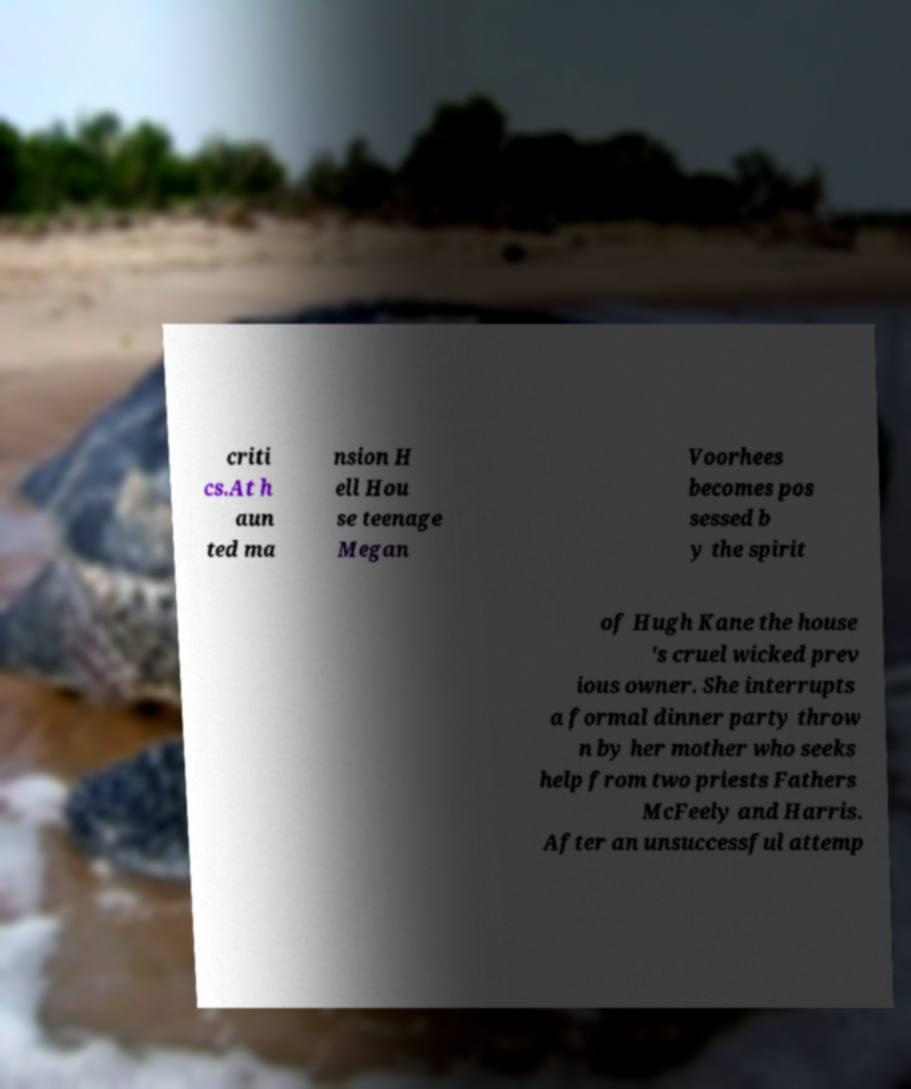Could you extract and type out the text from this image? criti cs.At h aun ted ma nsion H ell Hou se teenage Megan Voorhees becomes pos sessed b y the spirit of Hugh Kane the house 's cruel wicked prev ious owner. She interrupts a formal dinner party throw n by her mother who seeks help from two priests Fathers McFeely and Harris. After an unsuccessful attemp 